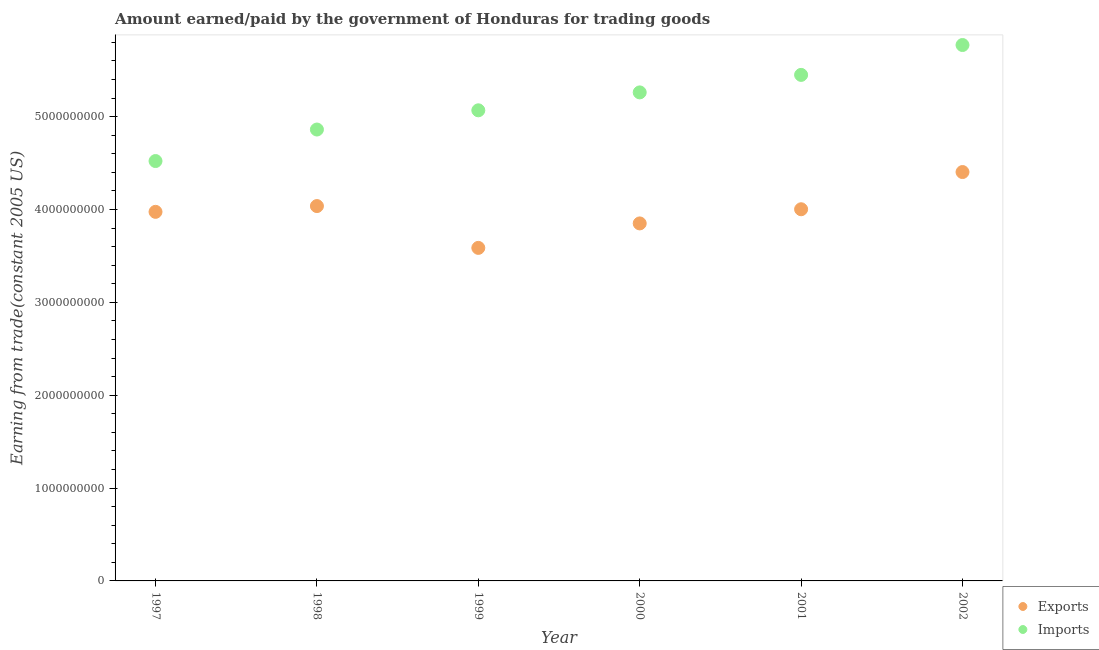What is the amount earned from exports in 2001?
Your answer should be very brief. 4.00e+09. Across all years, what is the maximum amount paid for imports?
Your response must be concise. 5.77e+09. Across all years, what is the minimum amount paid for imports?
Provide a succinct answer. 4.52e+09. In which year was the amount paid for imports maximum?
Keep it short and to the point. 2002. In which year was the amount earned from exports minimum?
Offer a terse response. 1999. What is the total amount paid for imports in the graph?
Provide a short and direct response. 3.09e+1. What is the difference between the amount paid for imports in 1997 and that in 2001?
Your response must be concise. -9.28e+08. What is the difference between the amount earned from exports in 1999 and the amount paid for imports in 1998?
Your answer should be very brief. -1.27e+09. What is the average amount earned from exports per year?
Your answer should be very brief. 3.98e+09. In the year 1998, what is the difference between the amount earned from exports and amount paid for imports?
Keep it short and to the point. -8.24e+08. In how many years, is the amount paid for imports greater than 2600000000 US$?
Keep it short and to the point. 6. What is the ratio of the amount earned from exports in 1998 to that in 2001?
Provide a succinct answer. 1.01. What is the difference between the highest and the second highest amount paid for imports?
Ensure brevity in your answer.  3.22e+08. What is the difference between the highest and the lowest amount paid for imports?
Provide a succinct answer. 1.25e+09. In how many years, is the amount paid for imports greater than the average amount paid for imports taken over all years?
Keep it short and to the point. 3. Does the amount earned from exports monotonically increase over the years?
Make the answer very short. No. How many dotlines are there?
Ensure brevity in your answer.  2. How many years are there in the graph?
Provide a succinct answer. 6. What is the difference between two consecutive major ticks on the Y-axis?
Your response must be concise. 1.00e+09. Does the graph contain any zero values?
Your answer should be very brief. No. Does the graph contain grids?
Your response must be concise. No. Where does the legend appear in the graph?
Your answer should be very brief. Bottom right. What is the title of the graph?
Ensure brevity in your answer.  Amount earned/paid by the government of Honduras for trading goods. Does "Secondary Education" appear as one of the legend labels in the graph?
Provide a short and direct response. No. What is the label or title of the Y-axis?
Offer a terse response. Earning from trade(constant 2005 US). What is the Earning from trade(constant 2005 US) of Exports in 1997?
Your answer should be very brief. 3.97e+09. What is the Earning from trade(constant 2005 US) in Imports in 1997?
Provide a succinct answer. 4.52e+09. What is the Earning from trade(constant 2005 US) in Exports in 1998?
Your response must be concise. 4.04e+09. What is the Earning from trade(constant 2005 US) in Imports in 1998?
Your answer should be very brief. 4.86e+09. What is the Earning from trade(constant 2005 US) of Exports in 1999?
Your response must be concise. 3.59e+09. What is the Earning from trade(constant 2005 US) in Imports in 1999?
Give a very brief answer. 5.07e+09. What is the Earning from trade(constant 2005 US) of Exports in 2000?
Provide a succinct answer. 3.85e+09. What is the Earning from trade(constant 2005 US) in Imports in 2000?
Your answer should be very brief. 5.26e+09. What is the Earning from trade(constant 2005 US) of Exports in 2001?
Make the answer very short. 4.00e+09. What is the Earning from trade(constant 2005 US) of Imports in 2001?
Keep it short and to the point. 5.45e+09. What is the Earning from trade(constant 2005 US) of Exports in 2002?
Provide a succinct answer. 4.40e+09. What is the Earning from trade(constant 2005 US) in Imports in 2002?
Offer a very short reply. 5.77e+09. Across all years, what is the maximum Earning from trade(constant 2005 US) in Exports?
Provide a short and direct response. 4.40e+09. Across all years, what is the maximum Earning from trade(constant 2005 US) in Imports?
Your answer should be compact. 5.77e+09. Across all years, what is the minimum Earning from trade(constant 2005 US) in Exports?
Make the answer very short. 3.59e+09. Across all years, what is the minimum Earning from trade(constant 2005 US) in Imports?
Provide a short and direct response. 4.52e+09. What is the total Earning from trade(constant 2005 US) of Exports in the graph?
Provide a succinct answer. 2.39e+1. What is the total Earning from trade(constant 2005 US) of Imports in the graph?
Make the answer very short. 3.09e+1. What is the difference between the Earning from trade(constant 2005 US) of Exports in 1997 and that in 1998?
Ensure brevity in your answer.  -6.23e+07. What is the difference between the Earning from trade(constant 2005 US) in Imports in 1997 and that in 1998?
Keep it short and to the point. -3.39e+08. What is the difference between the Earning from trade(constant 2005 US) in Exports in 1997 and that in 1999?
Keep it short and to the point. 3.88e+08. What is the difference between the Earning from trade(constant 2005 US) in Imports in 1997 and that in 1999?
Give a very brief answer. -5.46e+08. What is the difference between the Earning from trade(constant 2005 US) in Exports in 1997 and that in 2000?
Offer a very short reply. 1.25e+08. What is the difference between the Earning from trade(constant 2005 US) of Imports in 1997 and that in 2000?
Ensure brevity in your answer.  -7.39e+08. What is the difference between the Earning from trade(constant 2005 US) in Exports in 1997 and that in 2001?
Give a very brief answer. -2.80e+07. What is the difference between the Earning from trade(constant 2005 US) of Imports in 1997 and that in 2001?
Give a very brief answer. -9.28e+08. What is the difference between the Earning from trade(constant 2005 US) of Exports in 1997 and that in 2002?
Ensure brevity in your answer.  -4.29e+08. What is the difference between the Earning from trade(constant 2005 US) of Imports in 1997 and that in 2002?
Provide a short and direct response. -1.25e+09. What is the difference between the Earning from trade(constant 2005 US) of Exports in 1998 and that in 1999?
Your answer should be compact. 4.50e+08. What is the difference between the Earning from trade(constant 2005 US) of Imports in 1998 and that in 1999?
Offer a terse response. -2.07e+08. What is the difference between the Earning from trade(constant 2005 US) of Exports in 1998 and that in 2000?
Your answer should be compact. 1.87e+08. What is the difference between the Earning from trade(constant 2005 US) of Imports in 1998 and that in 2000?
Provide a succinct answer. -4.00e+08. What is the difference between the Earning from trade(constant 2005 US) in Exports in 1998 and that in 2001?
Offer a terse response. 3.43e+07. What is the difference between the Earning from trade(constant 2005 US) of Imports in 1998 and that in 2001?
Give a very brief answer. -5.88e+08. What is the difference between the Earning from trade(constant 2005 US) in Exports in 1998 and that in 2002?
Make the answer very short. -3.66e+08. What is the difference between the Earning from trade(constant 2005 US) of Imports in 1998 and that in 2002?
Your answer should be compact. -9.10e+08. What is the difference between the Earning from trade(constant 2005 US) of Exports in 1999 and that in 2000?
Make the answer very short. -2.64e+08. What is the difference between the Earning from trade(constant 2005 US) in Imports in 1999 and that in 2000?
Provide a succinct answer. -1.93e+08. What is the difference between the Earning from trade(constant 2005 US) of Exports in 1999 and that in 2001?
Your response must be concise. -4.16e+08. What is the difference between the Earning from trade(constant 2005 US) in Imports in 1999 and that in 2001?
Ensure brevity in your answer.  -3.82e+08. What is the difference between the Earning from trade(constant 2005 US) in Exports in 1999 and that in 2002?
Your response must be concise. -8.17e+08. What is the difference between the Earning from trade(constant 2005 US) of Imports in 1999 and that in 2002?
Provide a short and direct response. -7.03e+08. What is the difference between the Earning from trade(constant 2005 US) of Exports in 2000 and that in 2001?
Make the answer very short. -1.52e+08. What is the difference between the Earning from trade(constant 2005 US) in Imports in 2000 and that in 2001?
Ensure brevity in your answer.  -1.89e+08. What is the difference between the Earning from trade(constant 2005 US) in Exports in 2000 and that in 2002?
Your response must be concise. -5.53e+08. What is the difference between the Earning from trade(constant 2005 US) of Imports in 2000 and that in 2002?
Provide a succinct answer. -5.10e+08. What is the difference between the Earning from trade(constant 2005 US) of Exports in 2001 and that in 2002?
Ensure brevity in your answer.  -4.01e+08. What is the difference between the Earning from trade(constant 2005 US) in Imports in 2001 and that in 2002?
Offer a terse response. -3.22e+08. What is the difference between the Earning from trade(constant 2005 US) of Exports in 1997 and the Earning from trade(constant 2005 US) of Imports in 1998?
Offer a terse response. -8.87e+08. What is the difference between the Earning from trade(constant 2005 US) of Exports in 1997 and the Earning from trade(constant 2005 US) of Imports in 1999?
Give a very brief answer. -1.09e+09. What is the difference between the Earning from trade(constant 2005 US) of Exports in 1997 and the Earning from trade(constant 2005 US) of Imports in 2000?
Offer a terse response. -1.29e+09. What is the difference between the Earning from trade(constant 2005 US) in Exports in 1997 and the Earning from trade(constant 2005 US) in Imports in 2001?
Offer a very short reply. -1.47e+09. What is the difference between the Earning from trade(constant 2005 US) in Exports in 1997 and the Earning from trade(constant 2005 US) in Imports in 2002?
Give a very brief answer. -1.80e+09. What is the difference between the Earning from trade(constant 2005 US) of Exports in 1998 and the Earning from trade(constant 2005 US) of Imports in 1999?
Offer a terse response. -1.03e+09. What is the difference between the Earning from trade(constant 2005 US) in Exports in 1998 and the Earning from trade(constant 2005 US) in Imports in 2000?
Ensure brevity in your answer.  -1.22e+09. What is the difference between the Earning from trade(constant 2005 US) of Exports in 1998 and the Earning from trade(constant 2005 US) of Imports in 2001?
Keep it short and to the point. -1.41e+09. What is the difference between the Earning from trade(constant 2005 US) of Exports in 1998 and the Earning from trade(constant 2005 US) of Imports in 2002?
Your response must be concise. -1.73e+09. What is the difference between the Earning from trade(constant 2005 US) of Exports in 1999 and the Earning from trade(constant 2005 US) of Imports in 2000?
Provide a succinct answer. -1.67e+09. What is the difference between the Earning from trade(constant 2005 US) of Exports in 1999 and the Earning from trade(constant 2005 US) of Imports in 2001?
Your response must be concise. -1.86e+09. What is the difference between the Earning from trade(constant 2005 US) in Exports in 1999 and the Earning from trade(constant 2005 US) in Imports in 2002?
Keep it short and to the point. -2.18e+09. What is the difference between the Earning from trade(constant 2005 US) of Exports in 2000 and the Earning from trade(constant 2005 US) of Imports in 2001?
Keep it short and to the point. -1.60e+09. What is the difference between the Earning from trade(constant 2005 US) in Exports in 2000 and the Earning from trade(constant 2005 US) in Imports in 2002?
Provide a short and direct response. -1.92e+09. What is the difference between the Earning from trade(constant 2005 US) in Exports in 2001 and the Earning from trade(constant 2005 US) in Imports in 2002?
Give a very brief answer. -1.77e+09. What is the average Earning from trade(constant 2005 US) in Exports per year?
Make the answer very short. 3.98e+09. What is the average Earning from trade(constant 2005 US) in Imports per year?
Provide a succinct answer. 5.16e+09. In the year 1997, what is the difference between the Earning from trade(constant 2005 US) in Exports and Earning from trade(constant 2005 US) in Imports?
Make the answer very short. -5.47e+08. In the year 1998, what is the difference between the Earning from trade(constant 2005 US) in Exports and Earning from trade(constant 2005 US) in Imports?
Your answer should be compact. -8.24e+08. In the year 1999, what is the difference between the Earning from trade(constant 2005 US) of Exports and Earning from trade(constant 2005 US) of Imports?
Ensure brevity in your answer.  -1.48e+09. In the year 2000, what is the difference between the Earning from trade(constant 2005 US) in Exports and Earning from trade(constant 2005 US) in Imports?
Provide a succinct answer. -1.41e+09. In the year 2001, what is the difference between the Earning from trade(constant 2005 US) in Exports and Earning from trade(constant 2005 US) in Imports?
Provide a short and direct response. -1.45e+09. In the year 2002, what is the difference between the Earning from trade(constant 2005 US) of Exports and Earning from trade(constant 2005 US) of Imports?
Your response must be concise. -1.37e+09. What is the ratio of the Earning from trade(constant 2005 US) in Exports in 1997 to that in 1998?
Your answer should be very brief. 0.98. What is the ratio of the Earning from trade(constant 2005 US) of Imports in 1997 to that in 1998?
Provide a short and direct response. 0.93. What is the ratio of the Earning from trade(constant 2005 US) in Exports in 1997 to that in 1999?
Make the answer very short. 1.11. What is the ratio of the Earning from trade(constant 2005 US) in Imports in 1997 to that in 1999?
Keep it short and to the point. 0.89. What is the ratio of the Earning from trade(constant 2005 US) in Exports in 1997 to that in 2000?
Your answer should be very brief. 1.03. What is the ratio of the Earning from trade(constant 2005 US) of Imports in 1997 to that in 2000?
Keep it short and to the point. 0.86. What is the ratio of the Earning from trade(constant 2005 US) of Imports in 1997 to that in 2001?
Your answer should be very brief. 0.83. What is the ratio of the Earning from trade(constant 2005 US) in Exports in 1997 to that in 2002?
Offer a very short reply. 0.9. What is the ratio of the Earning from trade(constant 2005 US) in Imports in 1997 to that in 2002?
Ensure brevity in your answer.  0.78. What is the ratio of the Earning from trade(constant 2005 US) of Exports in 1998 to that in 1999?
Your answer should be compact. 1.13. What is the ratio of the Earning from trade(constant 2005 US) of Imports in 1998 to that in 1999?
Your response must be concise. 0.96. What is the ratio of the Earning from trade(constant 2005 US) in Exports in 1998 to that in 2000?
Give a very brief answer. 1.05. What is the ratio of the Earning from trade(constant 2005 US) in Imports in 1998 to that in 2000?
Make the answer very short. 0.92. What is the ratio of the Earning from trade(constant 2005 US) in Exports in 1998 to that in 2001?
Your answer should be very brief. 1.01. What is the ratio of the Earning from trade(constant 2005 US) of Imports in 1998 to that in 2001?
Offer a very short reply. 0.89. What is the ratio of the Earning from trade(constant 2005 US) in Exports in 1998 to that in 2002?
Your answer should be compact. 0.92. What is the ratio of the Earning from trade(constant 2005 US) in Imports in 1998 to that in 2002?
Your answer should be compact. 0.84. What is the ratio of the Earning from trade(constant 2005 US) of Exports in 1999 to that in 2000?
Provide a succinct answer. 0.93. What is the ratio of the Earning from trade(constant 2005 US) in Imports in 1999 to that in 2000?
Keep it short and to the point. 0.96. What is the ratio of the Earning from trade(constant 2005 US) in Exports in 1999 to that in 2001?
Give a very brief answer. 0.9. What is the ratio of the Earning from trade(constant 2005 US) of Exports in 1999 to that in 2002?
Make the answer very short. 0.81. What is the ratio of the Earning from trade(constant 2005 US) of Imports in 1999 to that in 2002?
Your answer should be compact. 0.88. What is the ratio of the Earning from trade(constant 2005 US) of Exports in 2000 to that in 2001?
Give a very brief answer. 0.96. What is the ratio of the Earning from trade(constant 2005 US) of Imports in 2000 to that in 2001?
Provide a succinct answer. 0.97. What is the ratio of the Earning from trade(constant 2005 US) of Exports in 2000 to that in 2002?
Provide a short and direct response. 0.87. What is the ratio of the Earning from trade(constant 2005 US) in Imports in 2000 to that in 2002?
Keep it short and to the point. 0.91. What is the ratio of the Earning from trade(constant 2005 US) in Exports in 2001 to that in 2002?
Keep it short and to the point. 0.91. What is the ratio of the Earning from trade(constant 2005 US) of Imports in 2001 to that in 2002?
Give a very brief answer. 0.94. What is the difference between the highest and the second highest Earning from trade(constant 2005 US) in Exports?
Ensure brevity in your answer.  3.66e+08. What is the difference between the highest and the second highest Earning from trade(constant 2005 US) in Imports?
Ensure brevity in your answer.  3.22e+08. What is the difference between the highest and the lowest Earning from trade(constant 2005 US) of Exports?
Provide a short and direct response. 8.17e+08. What is the difference between the highest and the lowest Earning from trade(constant 2005 US) in Imports?
Offer a very short reply. 1.25e+09. 